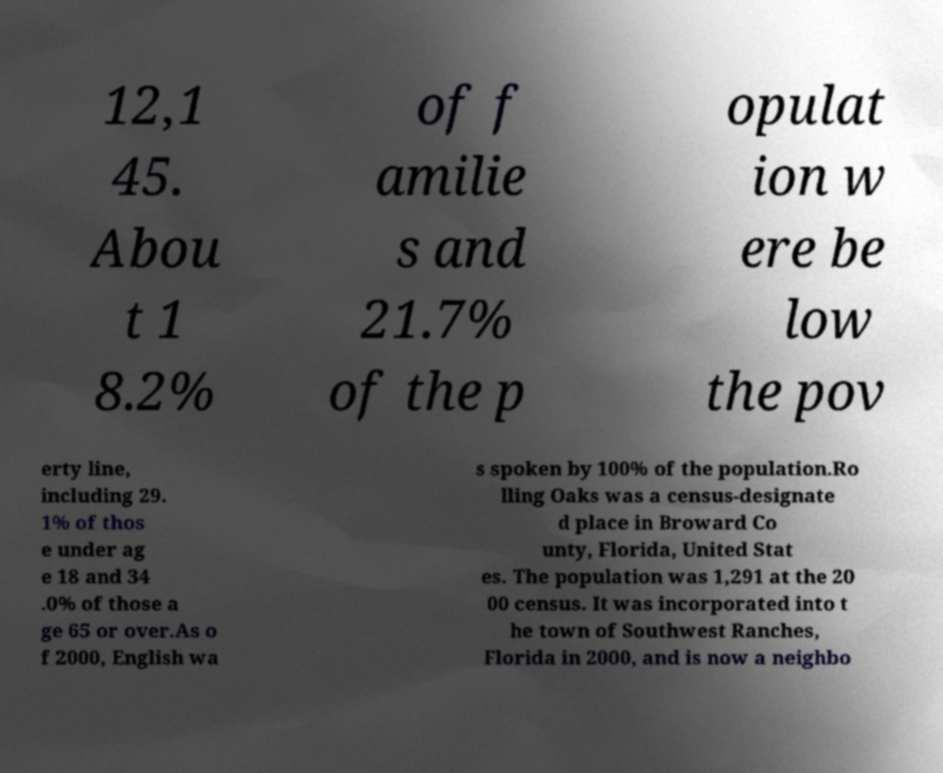Can you read and provide the text displayed in the image?This photo seems to have some interesting text. Can you extract and type it out for me? 12,1 45. Abou t 1 8.2% of f amilie s and 21.7% of the p opulat ion w ere be low the pov erty line, including 29. 1% of thos e under ag e 18 and 34 .0% of those a ge 65 or over.As o f 2000, English wa s spoken by 100% of the population.Ro lling Oaks was a census-designate d place in Broward Co unty, Florida, United Stat es. The population was 1,291 at the 20 00 census. It was incorporated into t he town of Southwest Ranches, Florida in 2000, and is now a neighbo 